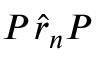<formula> <loc_0><loc_0><loc_500><loc_500>P _ { \Pi } \hat { r } _ { n } P _ { \Pi }</formula> 